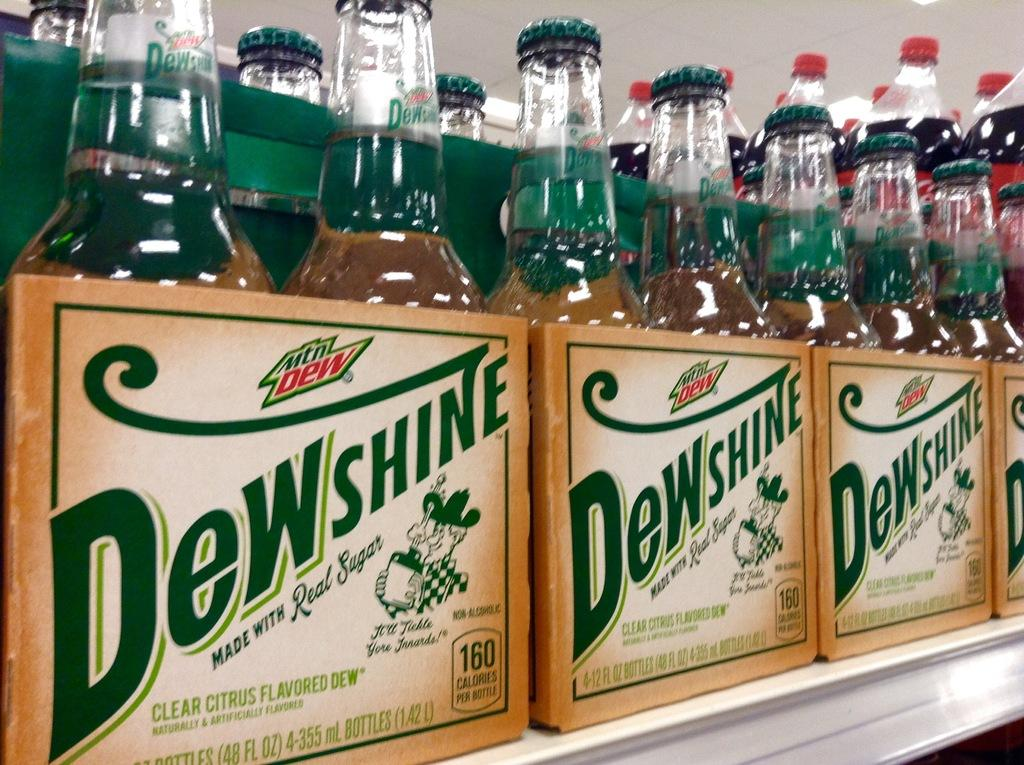<image>
Summarize the visual content of the image. A shelf with four packs of MtnDew that say Dewshine are in a store. 